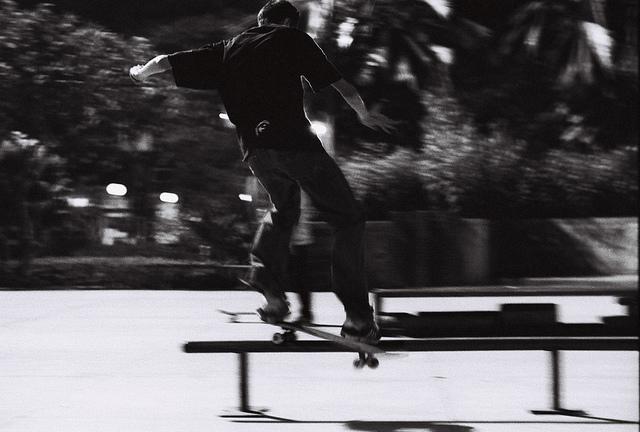Where is the skateboarder?
Give a very brief answer. In air. What is the person doing?
Write a very short answer. Skateboarding. Is the skateboard in the air or on the ground?
Short answer required. Air. 